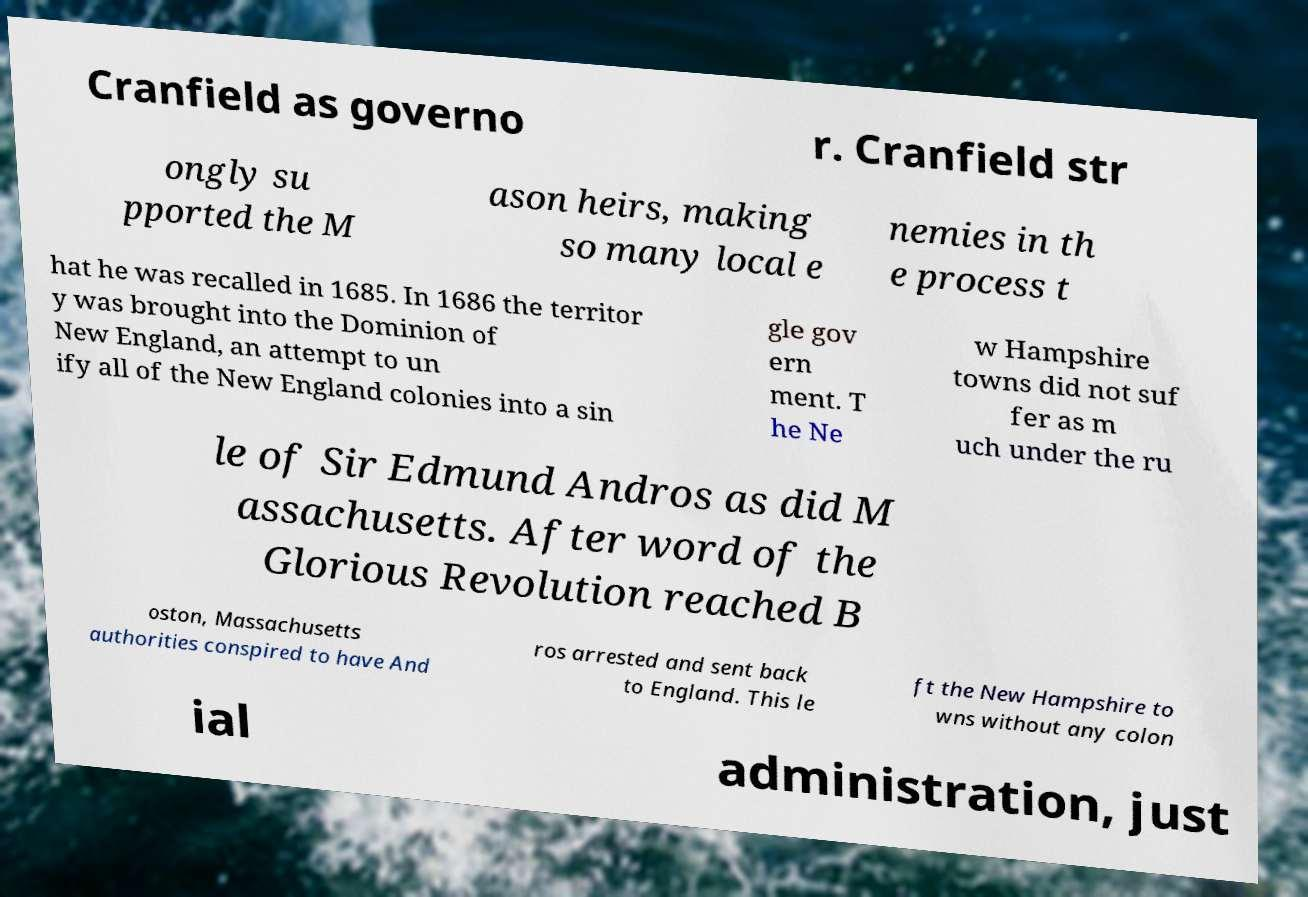For documentation purposes, I need the text within this image transcribed. Could you provide that? Cranfield as governo r. Cranfield str ongly su pported the M ason heirs, making so many local e nemies in th e process t hat he was recalled in 1685. In 1686 the territor y was brought into the Dominion of New England, an attempt to un ify all of the New England colonies into a sin gle gov ern ment. T he Ne w Hampshire towns did not suf fer as m uch under the ru le of Sir Edmund Andros as did M assachusetts. After word of the Glorious Revolution reached B oston, Massachusetts authorities conspired to have And ros arrested and sent back to England. This le ft the New Hampshire to wns without any colon ial administration, just 